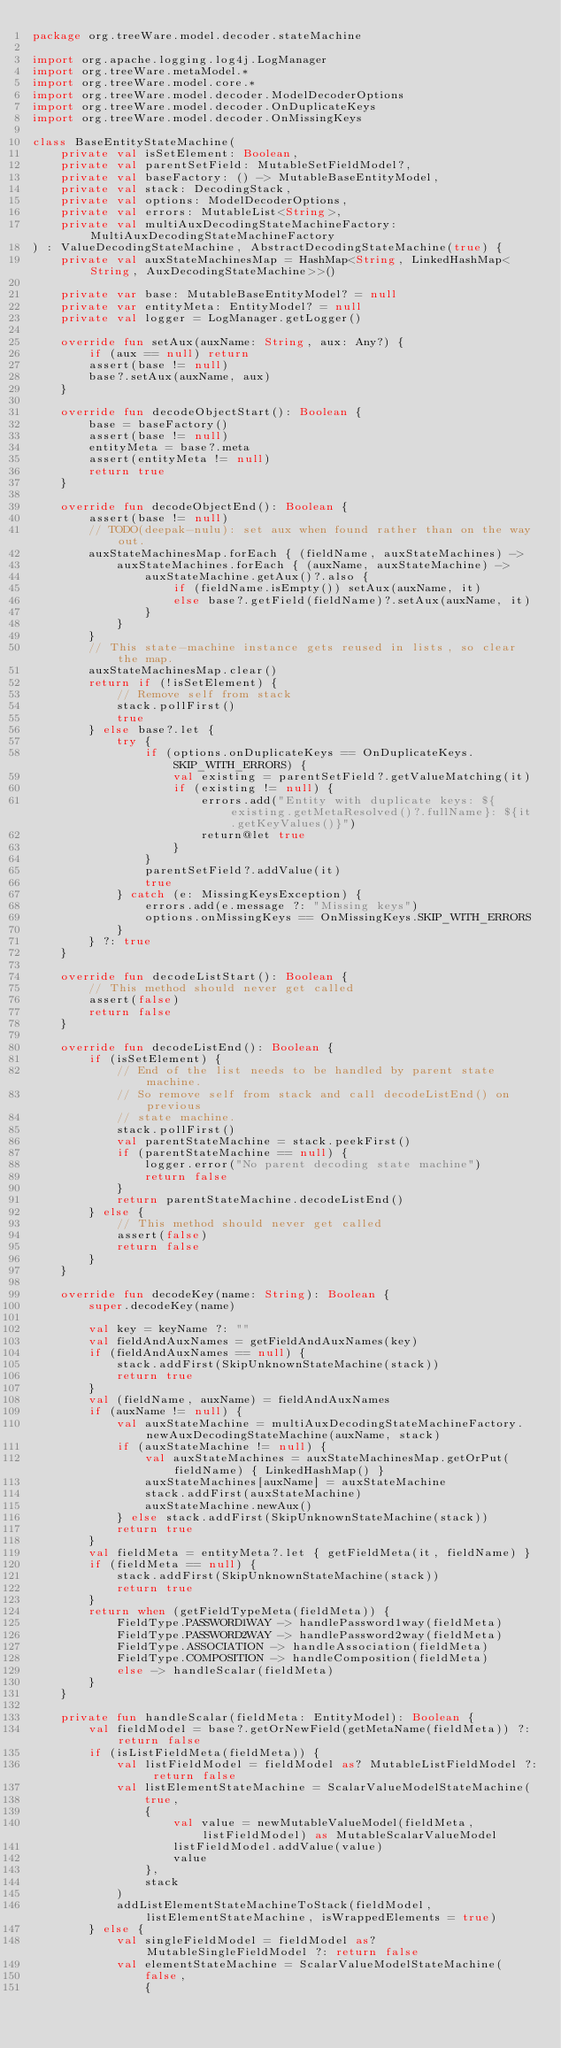<code> <loc_0><loc_0><loc_500><loc_500><_Kotlin_>package org.treeWare.model.decoder.stateMachine

import org.apache.logging.log4j.LogManager
import org.treeWare.metaModel.*
import org.treeWare.model.core.*
import org.treeWare.model.decoder.ModelDecoderOptions
import org.treeWare.model.decoder.OnDuplicateKeys
import org.treeWare.model.decoder.OnMissingKeys

class BaseEntityStateMachine(
    private val isSetElement: Boolean,
    private val parentSetField: MutableSetFieldModel?,
    private val baseFactory: () -> MutableBaseEntityModel,
    private val stack: DecodingStack,
    private val options: ModelDecoderOptions,
    private val errors: MutableList<String>,
    private val multiAuxDecodingStateMachineFactory: MultiAuxDecodingStateMachineFactory
) : ValueDecodingStateMachine, AbstractDecodingStateMachine(true) {
    private val auxStateMachinesMap = HashMap<String, LinkedHashMap<String, AuxDecodingStateMachine>>()

    private var base: MutableBaseEntityModel? = null
    private var entityMeta: EntityModel? = null
    private val logger = LogManager.getLogger()

    override fun setAux(auxName: String, aux: Any?) {
        if (aux == null) return
        assert(base != null)
        base?.setAux(auxName, aux)
    }

    override fun decodeObjectStart(): Boolean {
        base = baseFactory()
        assert(base != null)
        entityMeta = base?.meta
        assert(entityMeta != null)
        return true
    }

    override fun decodeObjectEnd(): Boolean {
        assert(base != null)
        // TODO(deepak-nulu): set aux when found rather than on the way out.
        auxStateMachinesMap.forEach { (fieldName, auxStateMachines) ->
            auxStateMachines.forEach { (auxName, auxStateMachine) ->
                auxStateMachine.getAux()?.also {
                    if (fieldName.isEmpty()) setAux(auxName, it)
                    else base?.getField(fieldName)?.setAux(auxName, it)
                }
            }
        }
        // This state-machine instance gets reused in lists, so clear the map.
        auxStateMachinesMap.clear()
        return if (!isSetElement) {
            // Remove self from stack
            stack.pollFirst()
            true
        } else base?.let {
            try {
                if (options.onDuplicateKeys == OnDuplicateKeys.SKIP_WITH_ERRORS) {
                    val existing = parentSetField?.getValueMatching(it)
                    if (existing != null) {
                        errors.add("Entity with duplicate keys: ${existing.getMetaResolved()?.fullName}: ${it.getKeyValues()}")
                        return@let true
                    }
                }
                parentSetField?.addValue(it)
                true
            } catch (e: MissingKeysException) {
                errors.add(e.message ?: "Missing keys")
                options.onMissingKeys == OnMissingKeys.SKIP_WITH_ERRORS
            }
        } ?: true
    }

    override fun decodeListStart(): Boolean {
        // This method should never get called
        assert(false)
        return false
    }

    override fun decodeListEnd(): Boolean {
        if (isSetElement) {
            // End of the list needs to be handled by parent state machine.
            // So remove self from stack and call decodeListEnd() on previous
            // state machine.
            stack.pollFirst()
            val parentStateMachine = stack.peekFirst()
            if (parentStateMachine == null) {
                logger.error("No parent decoding state machine")
                return false
            }
            return parentStateMachine.decodeListEnd()
        } else {
            // This method should never get called
            assert(false)
            return false
        }
    }

    override fun decodeKey(name: String): Boolean {
        super.decodeKey(name)

        val key = keyName ?: ""
        val fieldAndAuxNames = getFieldAndAuxNames(key)
        if (fieldAndAuxNames == null) {
            stack.addFirst(SkipUnknownStateMachine(stack))
            return true
        }
        val (fieldName, auxName) = fieldAndAuxNames
        if (auxName != null) {
            val auxStateMachine = multiAuxDecodingStateMachineFactory.newAuxDecodingStateMachine(auxName, stack)
            if (auxStateMachine != null) {
                val auxStateMachines = auxStateMachinesMap.getOrPut(fieldName) { LinkedHashMap() }
                auxStateMachines[auxName] = auxStateMachine
                stack.addFirst(auxStateMachine)
                auxStateMachine.newAux()
            } else stack.addFirst(SkipUnknownStateMachine(stack))
            return true
        }
        val fieldMeta = entityMeta?.let { getFieldMeta(it, fieldName) }
        if (fieldMeta == null) {
            stack.addFirst(SkipUnknownStateMachine(stack))
            return true
        }
        return when (getFieldTypeMeta(fieldMeta)) {
            FieldType.PASSWORD1WAY -> handlePassword1way(fieldMeta)
            FieldType.PASSWORD2WAY -> handlePassword2way(fieldMeta)
            FieldType.ASSOCIATION -> handleAssociation(fieldMeta)
            FieldType.COMPOSITION -> handleComposition(fieldMeta)
            else -> handleScalar(fieldMeta)
        }
    }

    private fun handleScalar(fieldMeta: EntityModel): Boolean {
        val fieldModel = base?.getOrNewField(getMetaName(fieldMeta)) ?: return false
        if (isListFieldMeta(fieldMeta)) {
            val listFieldModel = fieldModel as? MutableListFieldModel ?: return false
            val listElementStateMachine = ScalarValueModelStateMachine(
                true,
                {
                    val value = newMutableValueModel(fieldMeta, listFieldModel) as MutableScalarValueModel
                    listFieldModel.addValue(value)
                    value
                },
                stack
            )
            addListElementStateMachineToStack(fieldModel, listElementStateMachine, isWrappedElements = true)
        } else {
            val singleFieldModel = fieldModel as? MutableSingleFieldModel ?: return false
            val elementStateMachine = ScalarValueModelStateMachine(
                false,
                {</code> 